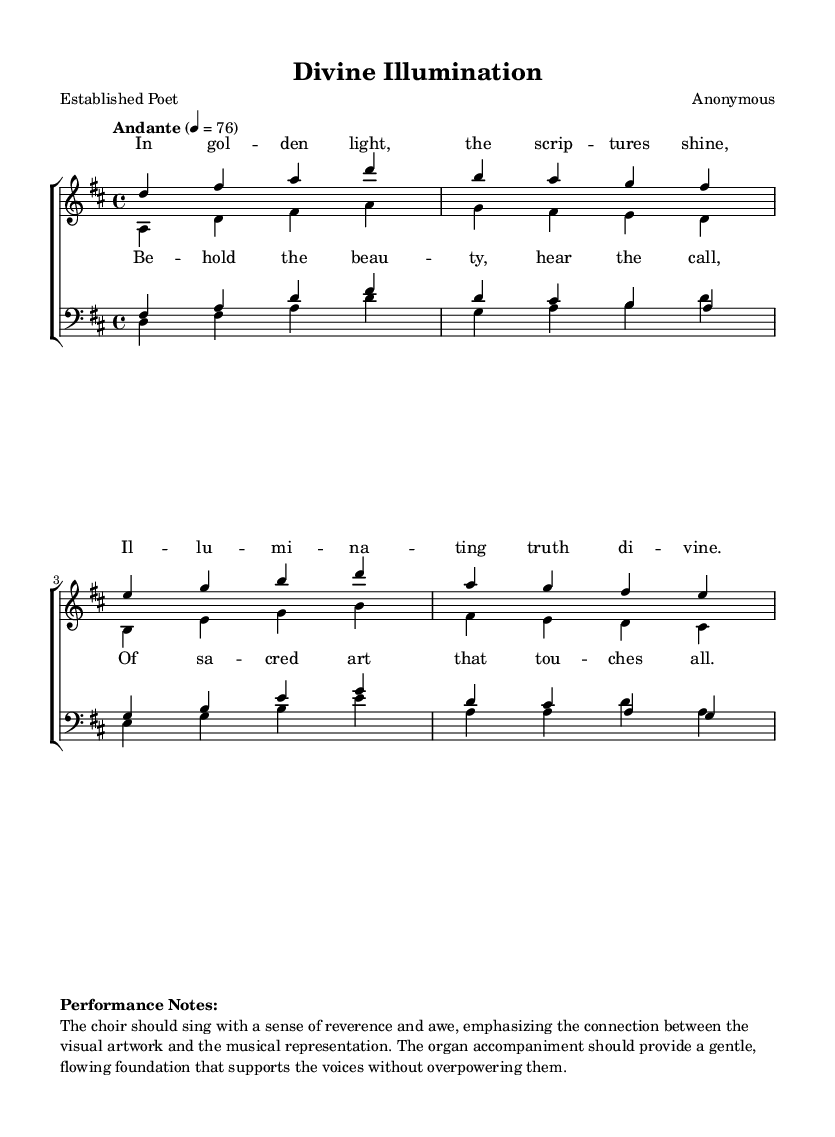What is the key signature of this music? The key signature is indicated by the sharp signs at the beginning of the score. In this case, there are two sharps (F# and C#), which indicates the key of D major.
Answer: D major What is the time signature of this music? The time signature is found at the beginning of the score following the key signature. Here, it is written as 4/4, meaning there are four beats in each measure and the quarter note gets one beat.
Answer: 4/4 What is the tempo marking for this piece? The tempo marking is noted at the beginning, indicating the speed of the music. Here, the tempo is "Andante," with a metronome marking provided as 76 beats per minute.
Answer: Andante How many vocal parts are in this choir arrangement? By examining the score, we can see that there are four distinct vocal parts: soprano, alto, tenor, and bass. Therefore, the total number of vocal parts is four.
Answer: Four What is the first line of the soprano lyrics? The first line of lyrics for the soprano part is shown below the notes specific to that voice. It reads, "In gol -- den light, the scrip -- tures shine."
Answer: In golden light, the scriptures shine How many measures are in the soprano melody? To find the number of measures in the soprano melody, we count each segmented box of music (measure) provided in the notation. In total, there are 4 measures for the soprano.
Answer: Four What is the main theme reflected in the chorus lyrics? The chorus lyrics convey a strong sense of appreciation for sacred art, emphasizing beauty and a spiritual connection. The theme focuses on the impact and beauty of sacred art.
Answer: Sacred art 